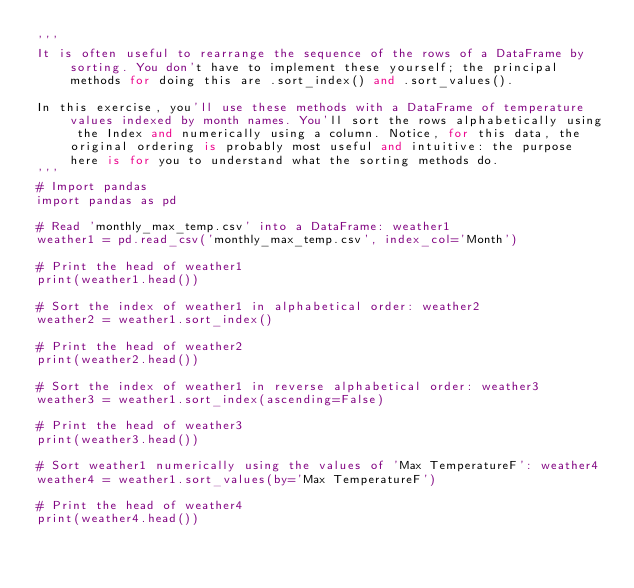<code> <loc_0><loc_0><loc_500><loc_500><_Python_>'''
It is often useful to rearrange the sequence of the rows of a DataFrame by sorting. You don't have to implement these yourself; the principal methods for doing this are .sort_index() and .sort_values().

In this exercise, you'll use these methods with a DataFrame of temperature values indexed by month names. You'll sort the rows alphabetically using the Index and numerically using a column. Notice, for this data, the original ordering is probably most useful and intuitive: the purpose here is for you to understand what the sorting methods do.
'''
# Import pandas
import pandas as pd

# Read 'monthly_max_temp.csv' into a DataFrame: weather1
weather1 = pd.read_csv('monthly_max_temp.csv', index_col='Month')

# Print the head of weather1
print(weather1.head())

# Sort the index of weather1 in alphabetical order: weather2
weather2 = weather1.sort_index()

# Print the head of weather2
print(weather2.head())

# Sort the index of weather1 in reverse alphabetical order: weather3
weather3 = weather1.sort_index(ascending=False)

# Print the head of weather3
print(weather3.head())

# Sort weather1 numerically using the values of 'Max TemperatureF': weather4
weather4 = weather1.sort_values(by='Max TemperatureF')

# Print the head of weather4
print(weather4.head())</code> 